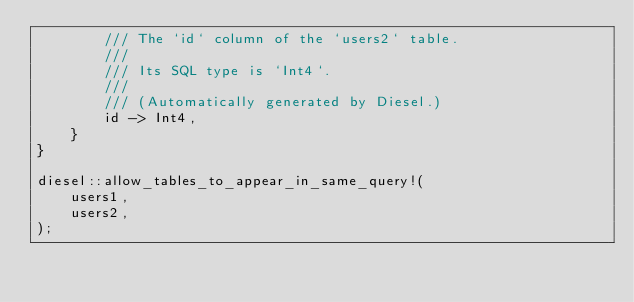Convert code to text. <code><loc_0><loc_0><loc_500><loc_500><_Rust_>        /// The `id` column of the `users2` table.
        ///
        /// Its SQL type is `Int4`.
        ///
        /// (Automatically generated by Diesel.)
        id -> Int4,
    }
}

diesel::allow_tables_to_appear_in_same_query!(
    users1,
    users2,
);
</code> 